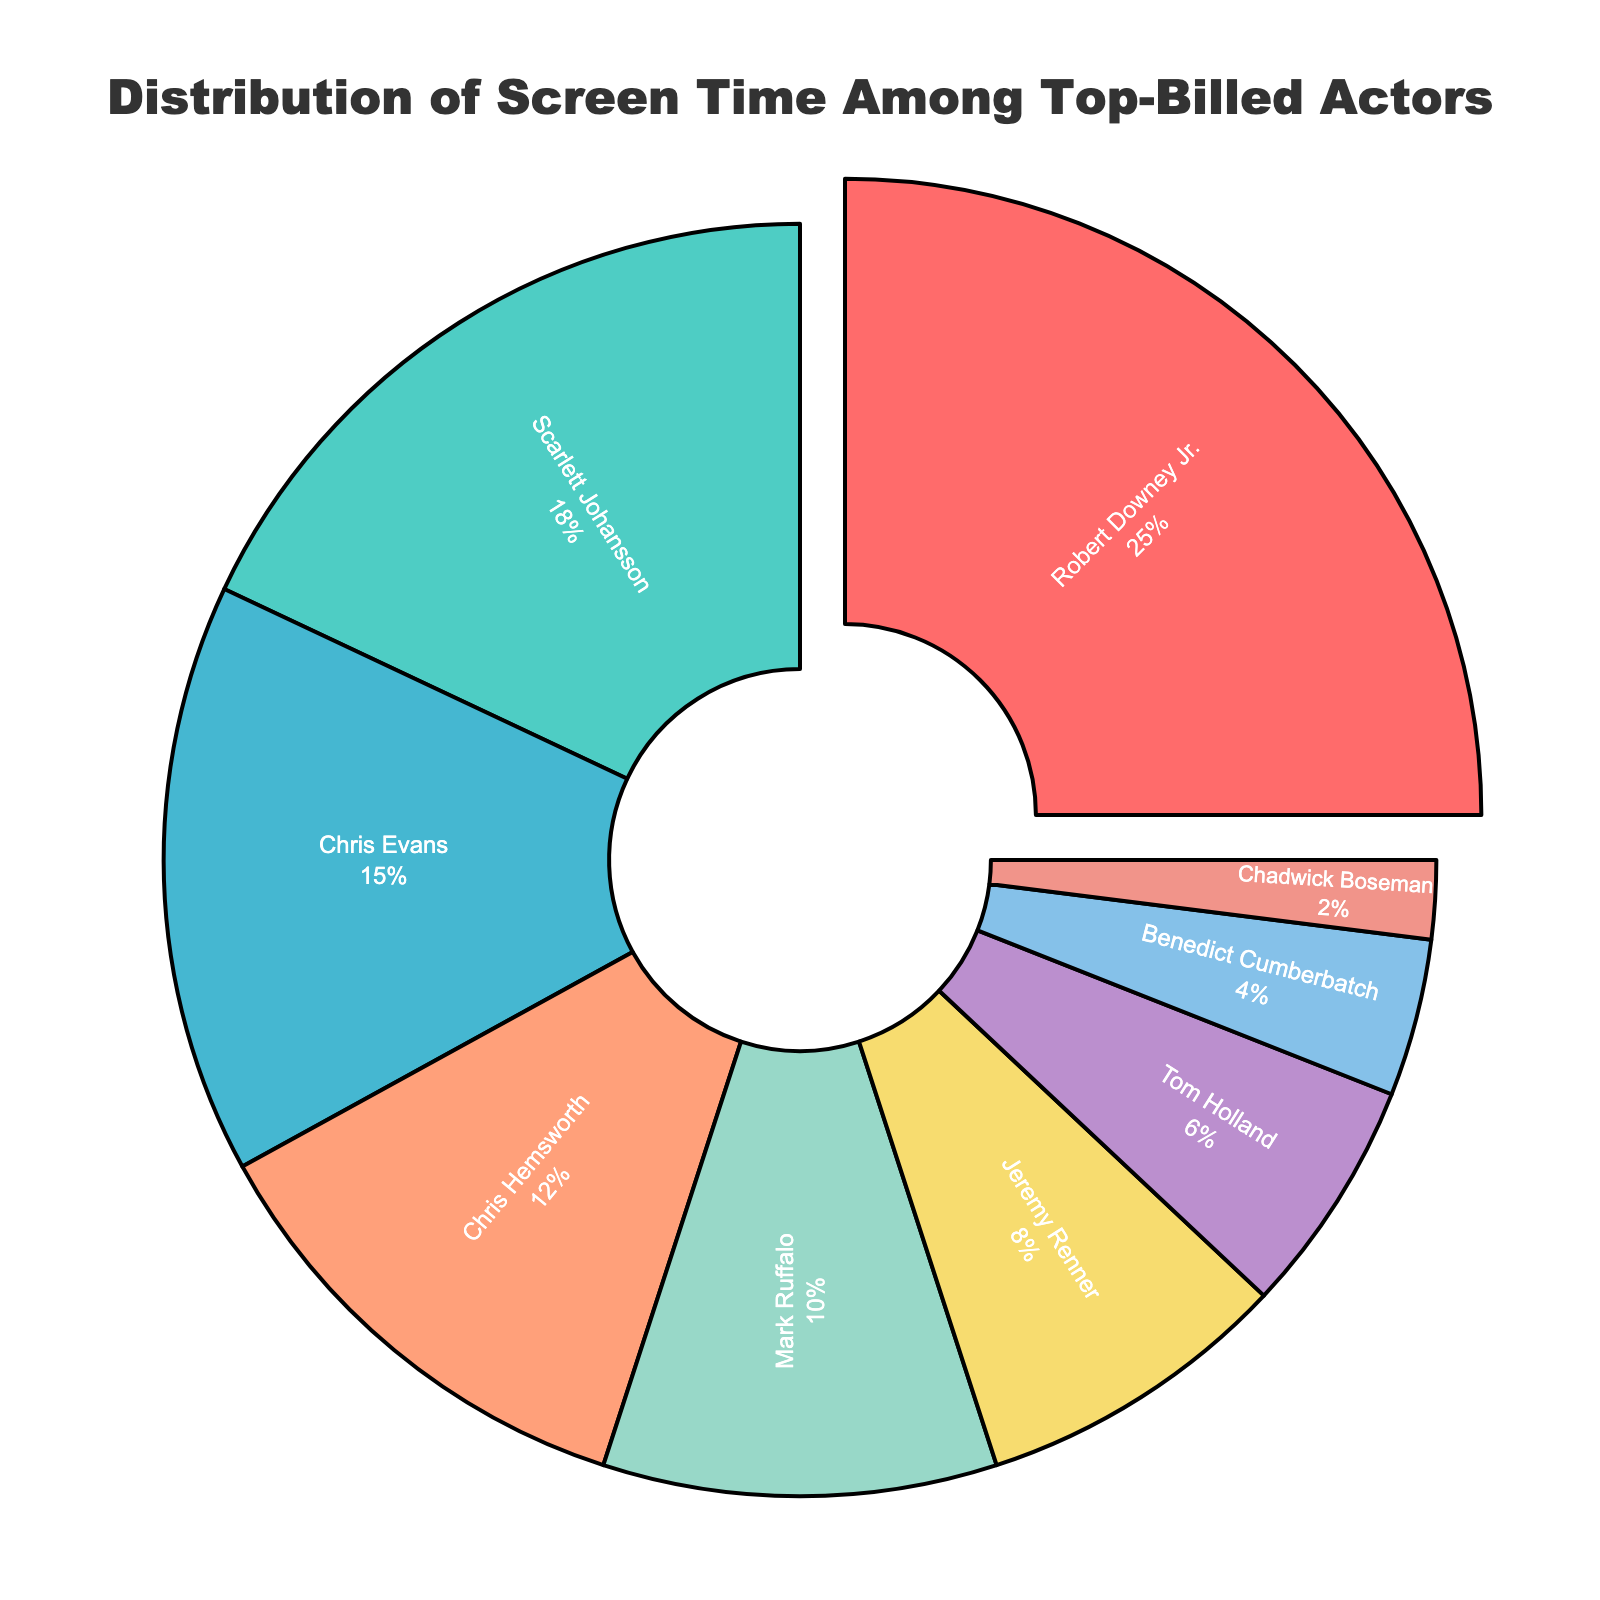Which actor has the greatest share of screen time? According to the pie chart, the actor with the largest slice of the pie is Robert Downey Jr.
Answer: Robert Downey Jr How much more screen time does Robert Downey Jr. have compared to Chris Evans? From the pie chart, Robert Downey Jr. has 25% screen time and Chris Evans has 15%. The difference is 25% - 15% = 10%.
Answer: 10% Which actors share less than 10% of the screen time? The actors whose slices are smaller and have percentages less than 10% are Jeremy Renner, Tom Holland, Benedict Cumberbatch, and Chadwick Boseman.
Answer: Jeremy Renner, Tom Holland, Benedict Cumberbatch, Chadwick Boseman What is the combined screen time percentage for the actors named Chris (Chris Evans and Chris Hemsworth)? Chris Evans has 15% and Chris Hemsworth has 12%. Their combined screen time is 15% + 12% = 27%.
Answer: 27% Which slice in the pie chart is colored red? The colors are arranged in the sequence of the actors listed. The first actor, Robert Downey Jr., has a red slice.
Answer: Robert Downey Jr Who has a smaller screen time percentage: Tom Holland or Benedict Cumberbatch? From the pie chart, Tom Holland has 6% and Benedict Cumberbatch has 4%. Benedict Cumberbatch has a smaller screen time percentage.
Answer: Benedict Cumberbatch What is the average screen time percentage for Scarlett Johansson and Mark Ruffalo? Scarlett Johansson has 18% and Mark Ruffalo has 10%. The average screen time percentage is (18% + 10%) / 2 = 14%.
Answer: 14% How many actors have a screen time percentage that is lower than the average screen time of Mark Ruffalo and Chris Hemsworth? Mark Ruffalo has 10% and Chris Hemsworth has 12%. The average is (10% + 12%) / 2 = 11%. The actors below this average are Jeremy Renner, Tom Holland, Benedict Cumberbatch, and Chadwick Boseman. There are 4 such actors.
Answer: 4 Comparing Scarlett Johansson and Robert Downey Jr., who has a smaller visual slice in the pie chart? Scarlett Johansson has 18%, and Robert Downey Jr. has 25%. Scarlett Johansson's slice is smaller.
Answer: Scarlett Johansson 